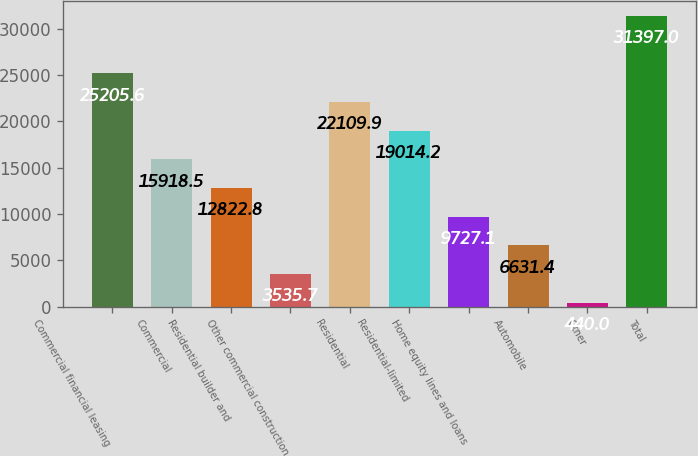Convert chart. <chart><loc_0><loc_0><loc_500><loc_500><bar_chart><fcel>Commercial financial leasing<fcel>Commercial<fcel>Residential builder and<fcel>Other commercial construction<fcel>Residential<fcel>Residential-limited<fcel>Home equity lines and loans<fcel>Automobile<fcel>Other<fcel>Total<nl><fcel>25205.6<fcel>15918.5<fcel>12822.8<fcel>3535.7<fcel>22109.9<fcel>19014.2<fcel>9727.1<fcel>6631.4<fcel>440<fcel>31397<nl></chart> 